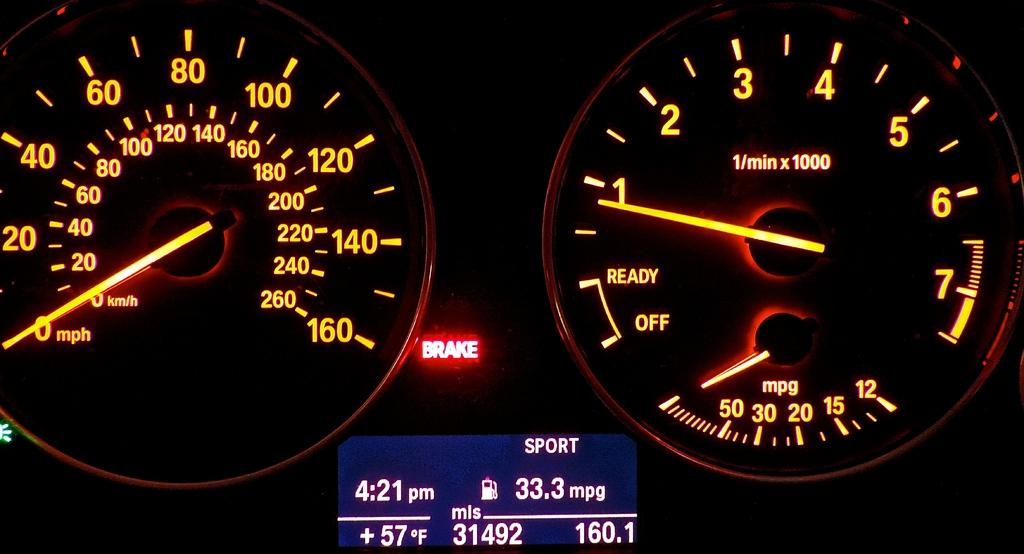<image>
Relay a brief, clear account of the picture shown. Two meters are displaying digits, one meter is 1 through 7. 